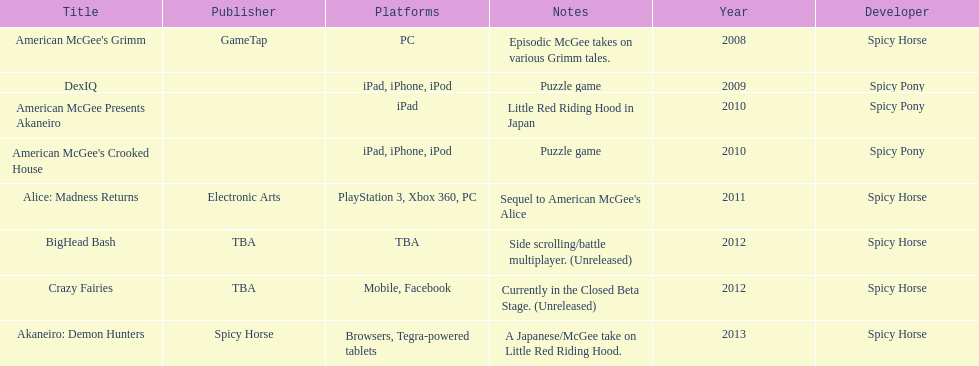What was the only game published by electronic arts? Alice: Madness Returns. 